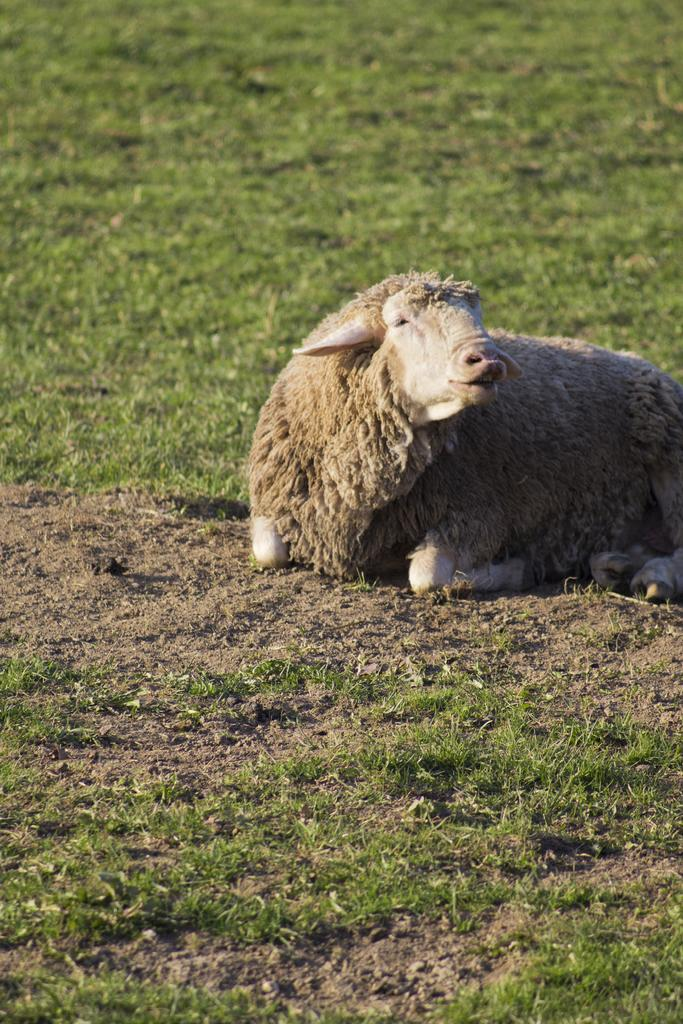What type of creature is in the image? There is an animal in the image. What colors can be seen on the animal? The animal is cream and brown in color. What position is the animal in? The animal is laying on the ground. What type of vegetation is present on the ground in the image? There is grass on the ground in the image. How many matches are visible in the image? There are no matches present in the image. What type of deer can be seen in the image? There is no deer present in the image; it is an animal with cream and brown colors. 